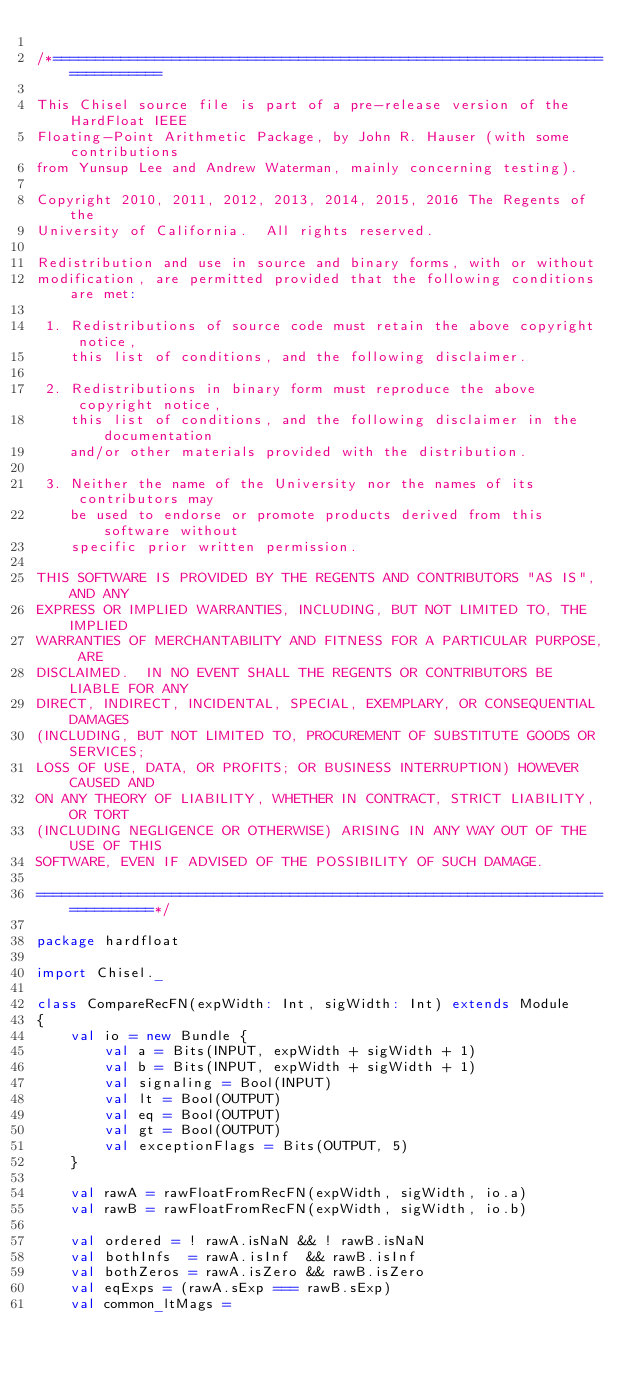<code> <loc_0><loc_0><loc_500><loc_500><_Scala_>
/*============================================================================

This Chisel source file is part of a pre-release version of the HardFloat IEEE
Floating-Point Arithmetic Package, by John R. Hauser (with some contributions
from Yunsup Lee and Andrew Waterman, mainly concerning testing).

Copyright 2010, 2011, 2012, 2013, 2014, 2015, 2016 The Regents of the
University of California.  All rights reserved.

Redistribution and use in source and binary forms, with or without
modification, are permitted provided that the following conditions are met:

 1. Redistributions of source code must retain the above copyright notice,
    this list of conditions, and the following disclaimer.

 2. Redistributions in binary form must reproduce the above copyright notice,
    this list of conditions, and the following disclaimer in the documentation
    and/or other materials provided with the distribution.

 3. Neither the name of the University nor the names of its contributors may
    be used to endorse or promote products derived from this software without
    specific prior written permission.

THIS SOFTWARE IS PROVIDED BY THE REGENTS AND CONTRIBUTORS "AS IS", AND ANY
EXPRESS OR IMPLIED WARRANTIES, INCLUDING, BUT NOT LIMITED TO, THE IMPLIED
WARRANTIES OF MERCHANTABILITY AND FITNESS FOR A PARTICULAR PURPOSE, ARE
DISCLAIMED.  IN NO EVENT SHALL THE REGENTS OR CONTRIBUTORS BE LIABLE FOR ANY
DIRECT, INDIRECT, INCIDENTAL, SPECIAL, EXEMPLARY, OR CONSEQUENTIAL DAMAGES
(INCLUDING, BUT NOT LIMITED TO, PROCUREMENT OF SUBSTITUTE GOODS OR SERVICES;
LOSS OF USE, DATA, OR PROFITS; OR BUSINESS INTERRUPTION) HOWEVER CAUSED AND
ON ANY THEORY OF LIABILITY, WHETHER IN CONTRACT, STRICT LIABILITY, OR TORT
(INCLUDING NEGLIGENCE OR OTHERWISE) ARISING IN ANY WAY OUT OF THE USE OF THIS
SOFTWARE, EVEN IF ADVISED OF THE POSSIBILITY OF SUCH DAMAGE.

=============================================================================*/

package hardfloat

import Chisel._

class CompareRecFN(expWidth: Int, sigWidth: Int) extends Module
{
    val io = new Bundle {
        val a = Bits(INPUT, expWidth + sigWidth + 1)
        val b = Bits(INPUT, expWidth + sigWidth + 1)
        val signaling = Bool(INPUT)
        val lt = Bool(OUTPUT)
        val eq = Bool(OUTPUT)
        val gt = Bool(OUTPUT)
        val exceptionFlags = Bits(OUTPUT, 5)
    }

    val rawA = rawFloatFromRecFN(expWidth, sigWidth, io.a)
    val rawB = rawFloatFromRecFN(expWidth, sigWidth, io.b)

    val ordered = ! rawA.isNaN && ! rawB.isNaN
    val bothInfs  = rawA.isInf  && rawB.isInf
    val bothZeros = rawA.isZero && rawB.isZero
    val eqExps = (rawA.sExp === rawB.sExp)
    val common_ltMags =</code> 